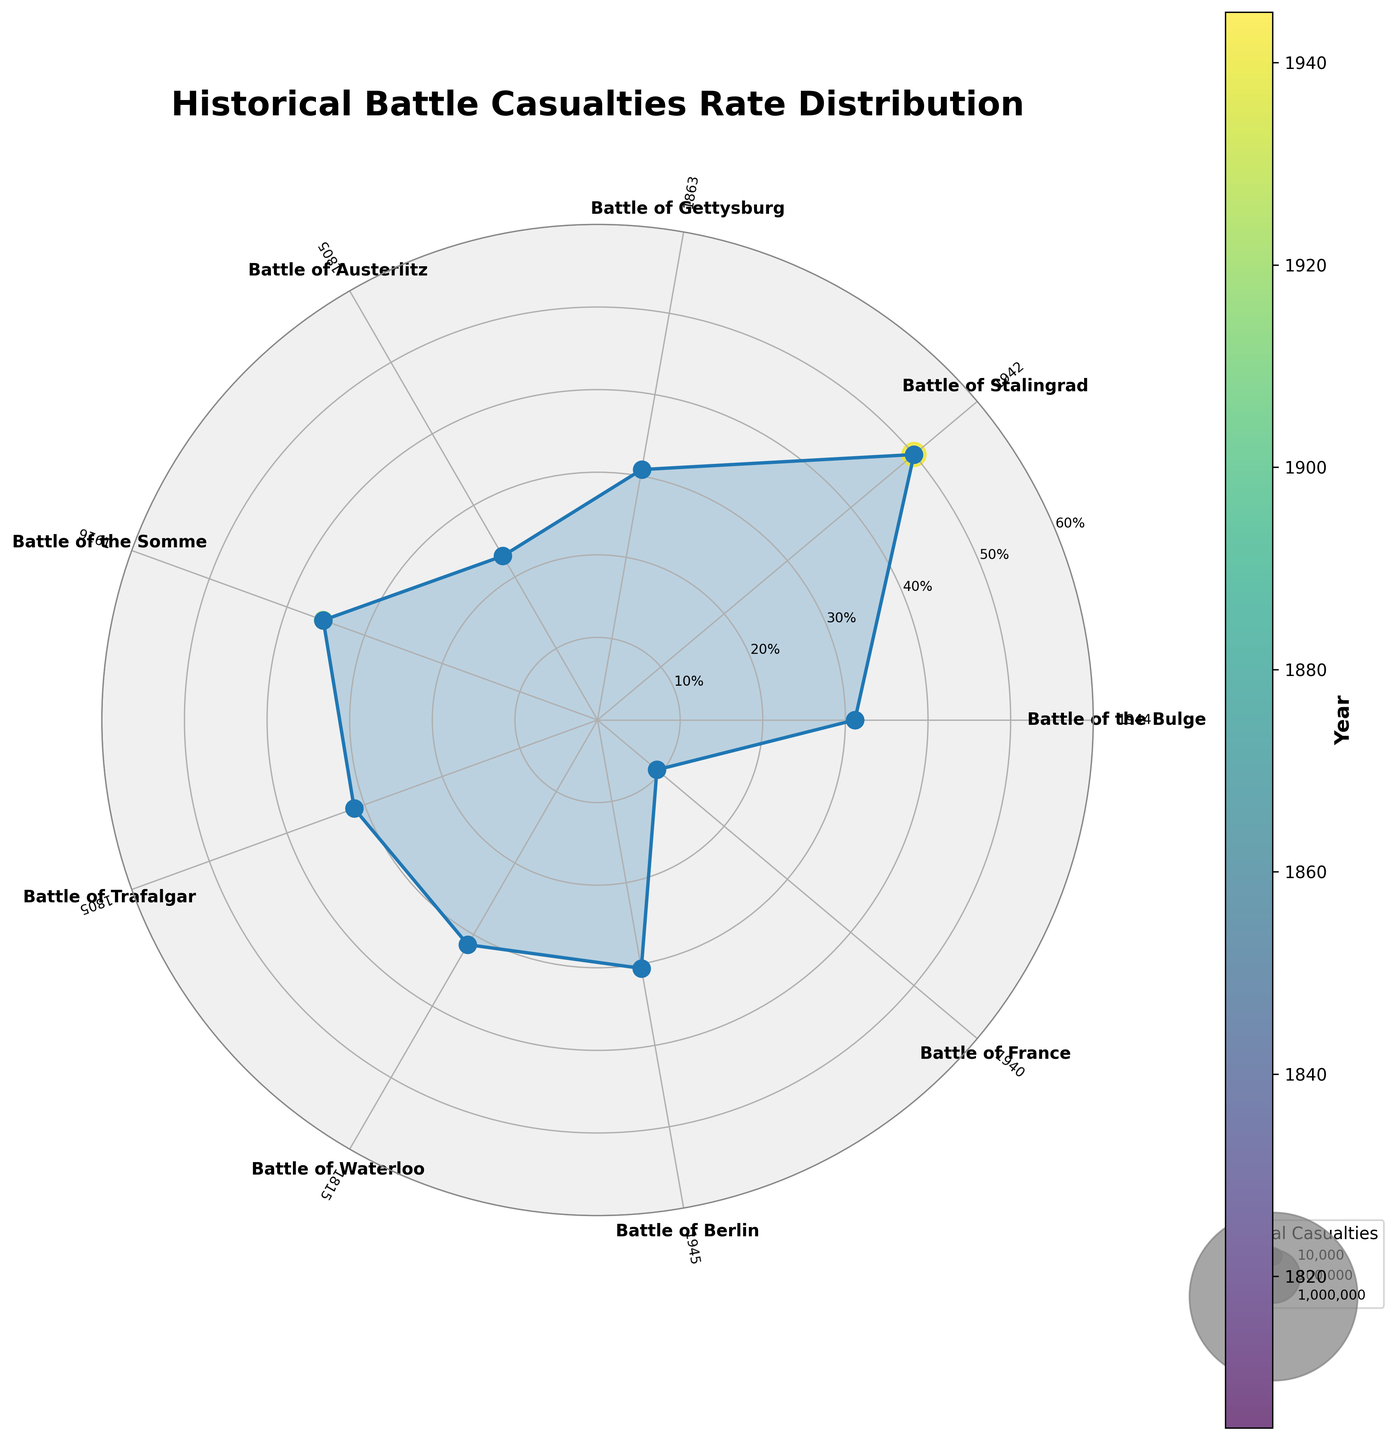What is the title of the chart? The title is located at the top of the chart. It reads "Historical Battle Casualties Rate Distribution."
Answer: Historical Battle Casualties Rate Distribution How many battles are depicted in the chart? By counting the labels around the outer circle of the chart, you can see there are 9 different battles listed.
Answer: 9 Which battle has the highest death rate? Observe the polar area chart and identify the point that extends the furthest from the center. The Battle of Stalingrad has the highest death rate at 50%.
Answer: Battle of Stalingrad What is the death rate for the Battle of Austerlitz? Look for the Battle of Austerlitz label on the outer circle and trace the corresponding line inward. The death rate for the Battle of Austerlitz is approximately 22.93%.
Answer: 22.93% Which two battles have similar death rates around 31%? Locate the points around the 30% marker on the polar area chart. The Battle of the Bulge, Battle of Gettysburg, Battle of Trafalgar, and Battle of Waterloo all have death rates close to 31%.
Answer: Battle of the Bulge, Battle of Gettysburg, Battle of Trafalgar, Battle of Waterloo What is the difference in the death rate between the Battle of the Somme and the Battle of France? The Battle of the Somme has a death rate of 35.33% and the Battle of France has a death rate of 9.38%. Subtract the lower death rate from the higher one: 35.33% - 9.38% = 25.95%.
Answer: 25.95% Which battle has the largest total casualties as indicated by the size of the scatter point? The size of the scatter points represents the total casualties. The largest point corresponds to the Battle of Stalingrad, which has 2,000,000 casualties.
Answer: Battle of Stalingrad Which battles occurred in Western Europe and how do their death rates compare? Locate the battles labeled Western Europe: Battle of the Bulge, Battle of the Somme, Battle of Trafalgar, and Battle of France. Their death rates are approximately 31.15%, 35.33%, 31.34%, and 9.38%, respectively.
Answer: Battle of the Bulge, Battle of the Somme, Battle of Trafalgar, Battle of France; 31.15%, 35.33%, 31.34%, 9.38% What is the average death rate across all battles? Add all the death rates and divide by the number of battles. The sum of the death rates is approximately 242.86%, and there are 9 battles. Therefore, the average death rate is 242.86% / 9 ≈ 26.99%.
Answer: 26.99% How does the death rate of the Battle of Berlin compare to the Battle of Waterloo? The Battle of Berlin has a death rate of 30.53%, and the Battle of Waterloo has a death rate of 31.41%. The Battle of Waterloo has a slightly higher death rate.
Answer: Battle of Waterloo is higher 